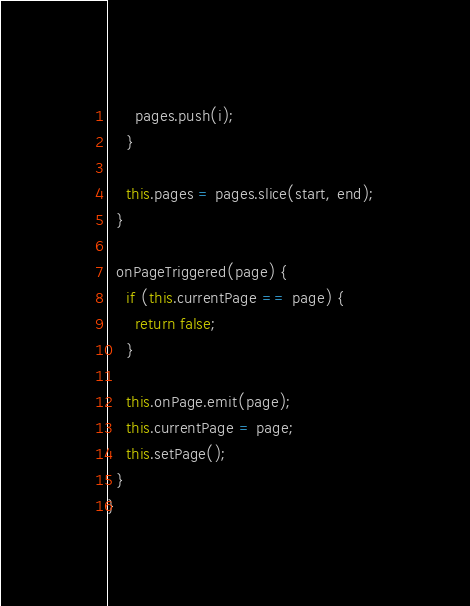Convert code to text. <code><loc_0><loc_0><loc_500><loc_500><_TypeScript_>      pages.push(i);
    }

    this.pages = pages.slice(start, end);
  }

  onPageTriggered(page) {
    if (this.currentPage == page) {
      return false;
    }

    this.onPage.emit(page);
    this.currentPage = page;
    this.setPage();
  }
}
</code> 